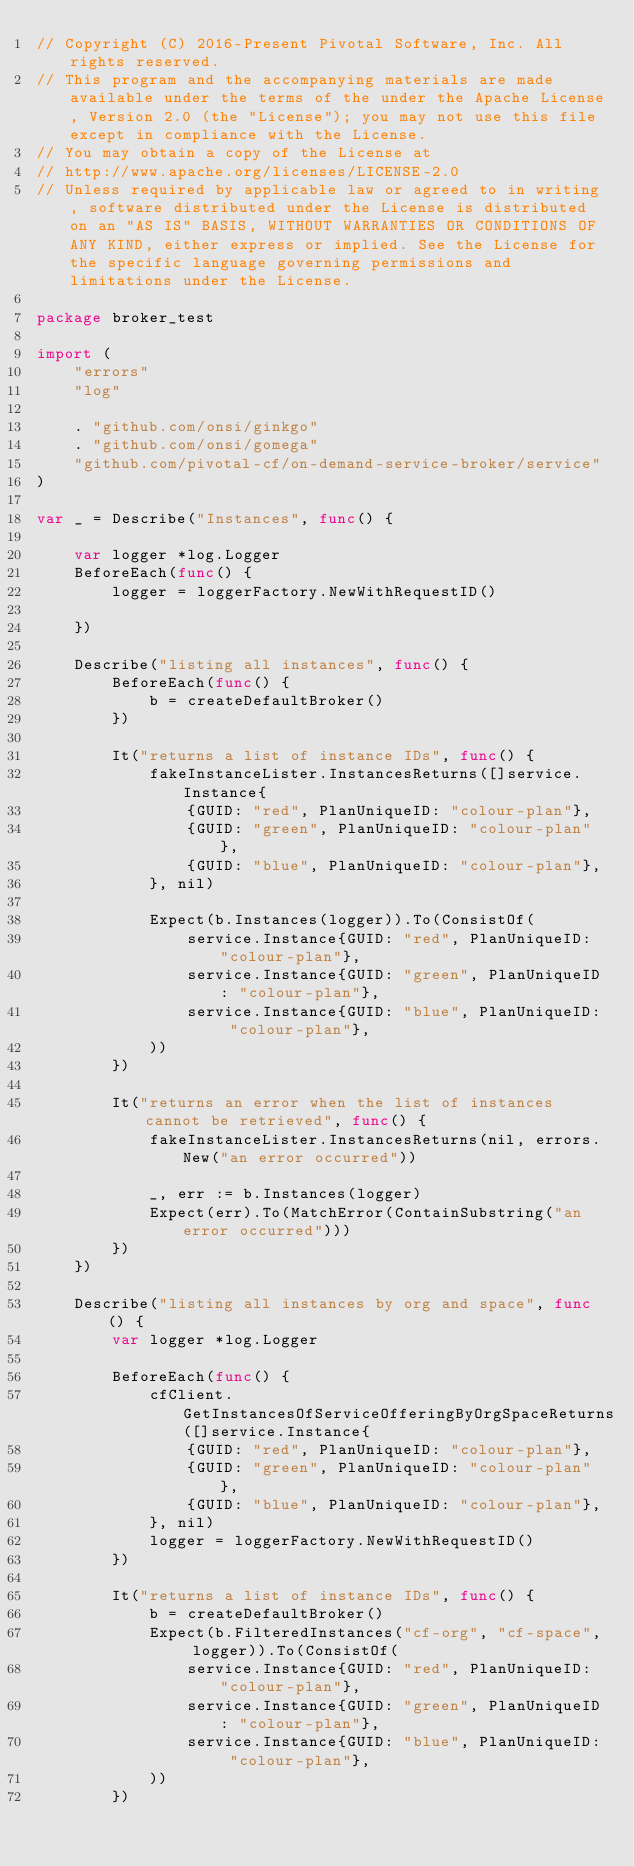Convert code to text. <code><loc_0><loc_0><loc_500><loc_500><_Go_>// Copyright (C) 2016-Present Pivotal Software, Inc. All rights reserved.
// This program and the accompanying materials are made available under the terms of the under the Apache License, Version 2.0 (the "License"); you may not use this file except in compliance with the License.
// You may obtain a copy of the License at
// http://www.apache.org/licenses/LICENSE-2.0
// Unless required by applicable law or agreed to in writing, software distributed under the License is distributed on an "AS IS" BASIS, WITHOUT WARRANTIES OR CONDITIONS OF ANY KIND, either express or implied. See the License for the specific language governing permissions and limitations under the License.

package broker_test

import (
	"errors"
	"log"

	. "github.com/onsi/ginkgo"
	. "github.com/onsi/gomega"
	"github.com/pivotal-cf/on-demand-service-broker/service"
)

var _ = Describe("Instances", func() {

	var logger *log.Logger
	BeforeEach(func() {
		logger = loggerFactory.NewWithRequestID()

	})

	Describe("listing all instances", func() {
		BeforeEach(func() {
			b = createDefaultBroker()
		})

		It("returns a list of instance IDs", func() {
			fakeInstanceLister.InstancesReturns([]service.Instance{
				{GUID: "red", PlanUniqueID: "colour-plan"},
				{GUID: "green", PlanUniqueID: "colour-plan"},
				{GUID: "blue", PlanUniqueID: "colour-plan"},
			}, nil)

			Expect(b.Instances(logger)).To(ConsistOf(
				service.Instance{GUID: "red", PlanUniqueID: "colour-plan"},
				service.Instance{GUID: "green", PlanUniqueID: "colour-plan"},
				service.Instance{GUID: "blue", PlanUniqueID: "colour-plan"},
			))
		})

		It("returns an error when the list of instances cannot be retrieved", func() {
			fakeInstanceLister.InstancesReturns(nil, errors.New("an error occurred"))

			_, err := b.Instances(logger)
			Expect(err).To(MatchError(ContainSubstring("an error occurred")))
		})
	})

	Describe("listing all instances by org and space", func() {
		var logger *log.Logger

		BeforeEach(func() {
			cfClient.GetInstancesOfServiceOfferingByOrgSpaceReturns([]service.Instance{
				{GUID: "red", PlanUniqueID: "colour-plan"},
				{GUID: "green", PlanUniqueID: "colour-plan"},
				{GUID: "blue", PlanUniqueID: "colour-plan"},
			}, nil)
			logger = loggerFactory.NewWithRequestID()
		})

		It("returns a list of instance IDs", func() {
			b = createDefaultBroker()
			Expect(b.FilteredInstances("cf-org", "cf-space", logger)).To(ConsistOf(
				service.Instance{GUID: "red", PlanUniqueID: "colour-plan"},
				service.Instance{GUID: "green", PlanUniqueID: "colour-plan"},
				service.Instance{GUID: "blue", PlanUniqueID: "colour-plan"},
			))
		})
</code> 